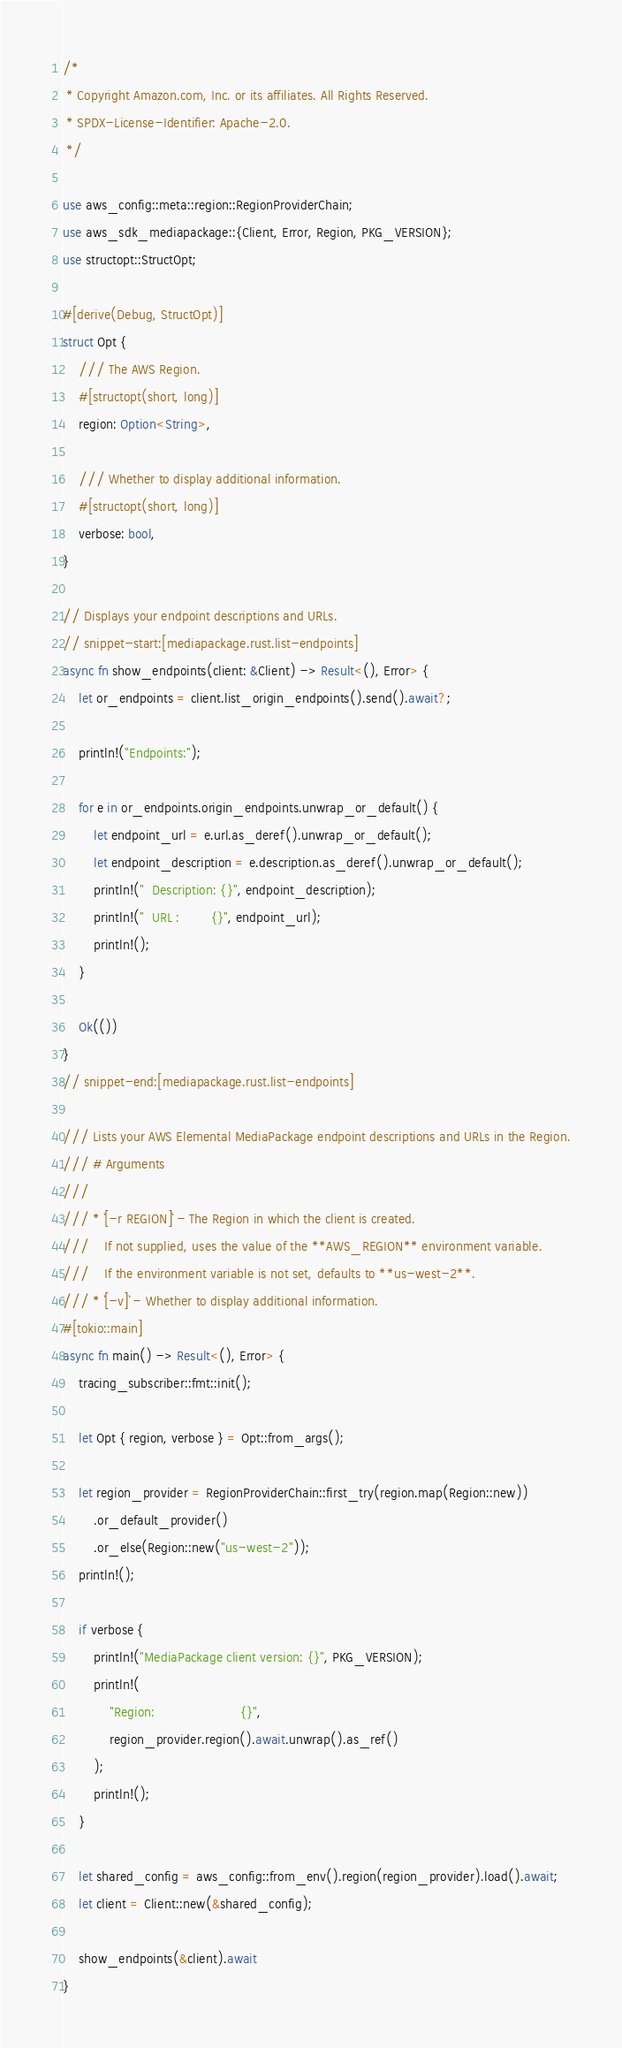Convert code to text. <code><loc_0><loc_0><loc_500><loc_500><_Rust_>/*
 * Copyright Amazon.com, Inc. or its affiliates. All Rights Reserved.
 * SPDX-License-Identifier: Apache-2.0.
 */

use aws_config::meta::region::RegionProviderChain;
use aws_sdk_mediapackage::{Client, Error, Region, PKG_VERSION};
use structopt::StructOpt;

#[derive(Debug, StructOpt)]
struct Opt {
    /// The AWS Region.
    #[structopt(short, long)]
    region: Option<String>,

    /// Whether to display additional information.
    #[structopt(short, long)]
    verbose: bool,
}

// Displays your endpoint descriptions and URLs.
// snippet-start:[mediapackage.rust.list-endpoints]
async fn show_endpoints(client: &Client) -> Result<(), Error> {
    let or_endpoints = client.list_origin_endpoints().send().await?;

    println!("Endpoints:");

    for e in or_endpoints.origin_endpoints.unwrap_or_default() {
        let endpoint_url = e.url.as_deref().unwrap_or_default();
        let endpoint_description = e.description.as_deref().unwrap_or_default();
        println!("  Description: {}", endpoint_description);
        println!("  URL :        {}", endpoint_url);
        println!();
    }

    Ok(())
}
// snippet-end:[mediapackage.rust.list-endpoints]

/// Lists your AWS Elemental MediaPackage endpoint descriptions and URLs in the Region.
/// # Arguments
///
/// * `[-r REGION]` - The Region in which the client is created.
///    If not supplied, uses the value of the **AWS_REGION** environment variable.
///    If the environment variable is not set, defaults to **us-west-2**.
/// * `[-v]` - Whether to display additional information.
#[tokio::main]
async fn main() -> Result<(), Error> {
    tracing_subscriber::fmt::init();

    let Opt { region, verbose } = Opt::from_args();

    let region_provider = RegionProviderChain::first_try(region.map(Region::new))
        .or_default_provider()
        .or_else(Region::new("us-west-2"));
    println!();

    if verbose {
        println!("MediaPackage client version: {}", PKG_VERSION);
        println!(
            "Region:                      {}",
            region_provider.region().await.unwrap().as_ref()
        );
        println!();
    }

    let shared_config = aws_config::from_env().region(region_provider).load().await;
    let client = Client::new(&shared_config);

    show_endpoints(&client).await
}
</code> 